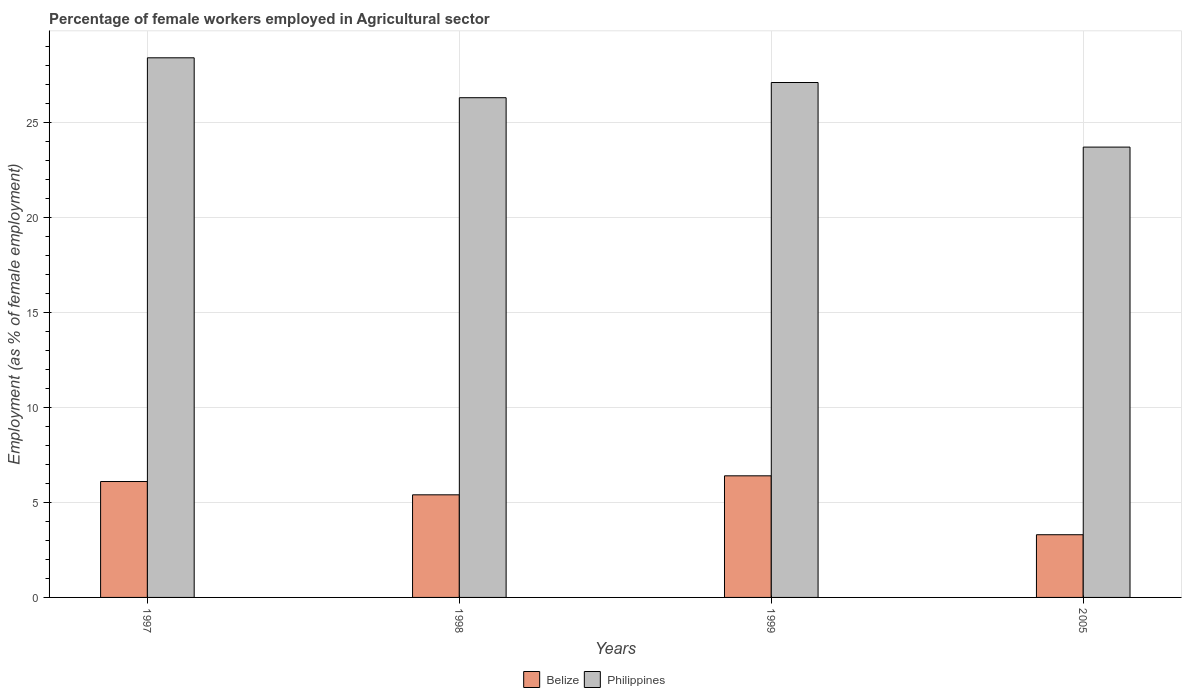How many different coloured bars are there?
Your answer should be compact. 2. Are the number of bars per tick equal to the number of legend labels?
Provide a short and direct response. Yes. How many bars are there on the 1st tick from the right?
Offer a terse response. 2. In how many cases, is the number of bars for a given year not equal to the number of legend labels?
Keep it short and to the point. 0. What is the percentage of females employed in Agricultural sector in Philippines in 1998?
Keep it short and to the point. 26.3. Across all years, what is the maximum percentage of females employed in Agricultural sector in Philippines?
Your answer should be very brief. 28.4. Across all years, what is the minimum percentage of females employed in Agricultural sector in Philippines?
Your answer should be very brief. 23.7. In which year was the percentage of females employed in Agricultural sector in Belize minimum?
Your response must be concise. 2005. What is the total percentage of females employed in Agricultural sector in Belize in the graph?
Ensure brevity in your answer.  21.2. What is the difference between the percentage of females employed in Agricultural sector in Belize in 1999 and that in 2005?
Keep it short and to the point. 3.1. What is the difference between the percentage of females employed in Agricultural sector in Philippines in 1998 and the percentage of females employed in Agricultural sector in Belize in 1997?
Offer a very short reply. 20.2. What is the average percentage of females employed in Agricultural sector in Philippines per year?
Your response must be concise. 26.37. In the year 1999, what is the difference between the percentage of females employed in Agricultural sector in Belize and percentage of females employed in Agricultural sector in Philippines?
Give a very brief answer. -20.7. In how many years, is the percentage of females employed in Agricultural sector in Philippines greater than 24 %?
Give a very brief answer. 3. What is the ratio of the percentage of females employed in Agricultural sector in Philippines in 1998 to that in 1999?
Make the answer very short. 0.97. Is the difference between the percentage of females employed in Agricultural sector in Belize in 1997 and 2005 greater than the difference between the percentage of females employed in Agricultural sector in Philippines in 1997 and 2005?
Your answer should be very brief. No. What is the difference between the highest and the second highest percentage of females employed in Agricultural sector in Belize?
Keep it short and to the point. 0.3. What is the difference between the highest and the lowest percentage of females employed in Agricultural sector in Philippines?
Provide a short and direct response. 4.7. How many bars are there?
Your answer should be very brief. 8. Are all the bars in the graph horizontal?
Offer a very short reply. No. How many years are there in the graph?
Offer a very short reply. 4. Are the values on the major ticks of Y-axis written in scientific E-notation?
Offer a terse response. No. Does the graph contain any zero values?
Give a very brief answer. No. Where does the legend appear in the graph?
Provide a short and direct response. Bottom center. What is the title of the graph?
Keep it short and to the point. Percentage of female workers employed in Agricultural sector. What is the label or title of the Y-axis?
Ensure brevity in your answer.  Employment (as % of female employment). What is the Employment (as % of female employment) of Belize in 1997?
Provide a succinct answer. 6.1. What is the Employment (as % of female employment) in Philippines in 1997?
Your response must be concise. 28.4. What is the Employment (as % of female employment) of Belize in 1998?
Your answer should be compact. 5.4. What is the Employment (as % of female employment) of Philippines in 1998?
Give a very brief answer. 26.3. What is the Employment (as % of female employment) in Belize in 1999?
Your answer should be compact. 6.4. What is the Employment (as % of female employment) in Philippines in 1999?
Provide a short and direct response. 27.1. What is the Employment (as % of female employment) of Belize in 2005?
Keep it short and to the point. 3.3. What is the Employment (as % of female employment) in Philippines in 2005?
Your answer should be very brief. 23.7. Across all years, what is the maximum Employment (as % of female employment) of Belize?
Provide a short and direct response. 6.4. Across all years, what is the maximum Employment (as % of female employment) in Philippines?
Make the answer very short. 28.4. Across all years, what is the minimum Employment (as % of female employment) of Belize?
Your answer should be compact. 3.3. Across all years, what is the minimum Employment (as % of female employment) in Philippines?
Your answer should be very brief. 23.7. What is the total Employment (as % of female employment) in Belize in the graph?
Your response must be concise. 21.2. What is the total Employment (as % of female employment) of Philippines in the graph?
Your answer should be compact. 105.5. What is the difference between the Employment (as % of female employment) of Belize in 1997 and that in 1998?
Your answer should be compact. 0.7. What is the difference between the Employment (as % of female employment) in Belize in 1997 and that in 1999?
Offer a terse response. -0.3. What is the difference between the Employment (as % of female employment) of Belize in 1997 and that in 2005?
Provide a succinct answer. 2.8. What is the difference between the Employment (as % of female employment) of Belize in 1998 and that in 1999?
Your response must be concise. -1. What is the difference between the Employment (as % of female employment) of Philippines in 1998 and that in 1999?
Offer a terse response. -0.8. What is the difference between the Employment (as % of female employment) in Belize in 1999 and that in 2005?
Ensure brevity in your answer.  3.1. What is the difference between the Employment (as % of female employment) in Philippines in 1999 and that in 2005?
Provide a short and direct response. 3.4. What is the difference between the Employment (as % of female employment) of Belize in 1997 and the Employment (as % of female employment) of Philippines in 1998?
Provide a succinct answer. -20.2. What is the difference between the Employment (as % of female employment) of Belize in 1997 and the Employment (as % of female employment) of Philippines in 1999?
Make the answer very short. -21. What is the difference between the Employment (as % of female employment) in Belize in 1997 and the Employment (as % of female employment) in Philippines in 2005?
Your response must be concise. -17.6. What is the difference between the Employment (as % of female employment) in Belize in 1998 and the Employment (as % of female employment) in Philippines in 1999?
Your answer should be compact. -21.7. What is the difference between the Employment (as % of female employment) in Belize in 1998 and the Employment (as % of female employment) in Philippines in 2005?
Provide a short and direct response. -18.3. What is the difference between the Employment (as % of female employment) of Belize in 1999 and the Employment (as % of female employment) of Philippines in 2005?
Offer a terse response. -17.3. What is the average Employment (as % of female employment) of Philippines per year?
Offer a terse response. 26.38. In the year 1997, what is the difference between the Employment (as % of female employment) of Belize and Employment (as % of female employment) of Philippines?
Provide a short and direct response. -22.3. In the year 1998, what is the difference between the Employment (as % of female employment) in Belize and Employment (as % of female employment) in Philippines?
Offer a terse response. -20.9. In the year 1999, what is the difference between the Employment (as % of female employment) of Belize and Employment (as % of female employment) of Philippines?
Give a very brief answer. -20.7. In the year 2005, what is the difference between the Employment (as % of female employment) in Belize and Employment (as % of female employment) in Philippines?
Give a very brief answer. -20.4. What is the ratio of the Employment (as % of female employment) in Belize in 1997 to that in 1998?
Ensure brevity in your answer.  1.13. What is the ratio of the Employment (as % of female employment) in Philippines in 1997 to that in 1998?
Offer a terse response. 1.08. What is the ratio of the Employment (as % of female employment) in Belize in 1997 to that in 1999?
Provide a short and direct response. 0.95. What is the ratio of the Employment (as % of female employment) in Philippines in 1997 to that in 1999?
Give a very brief answer. 1.05. What is the ratio of the Employment (as % of female employment) of Belize in 1997 to that in 2005?
Provide a succinct answer. 1.85. What is the ratio of the Employment (as % of female employment) of Philippines in 1997 to that in 2005?
Ensure brevity in your answer.  1.2. What is the ratio of the Employment (as % of female employment) in Belize in 1998 to that in 1999?
Offer a very short reply. 0.84. What is the ratio of the Employment (as % of female employment) in Philippines in 1998 to that in 1999?
Provide a short and direct response. 0.97. What is the ratio of the Employment (as % of female employment) in Belize in 1998 to that in 2005?
Make the answer very short. 1.64. What is the ratio of the Employment (as % of female employment) of Philippines in 1998 to that in 2005?
Offer a very short reply. 1.11. What is the ratio of the Employment (as % of female employment) in Belize in 1999 to that in 2005?
Provide a short and direct response. 1.94. What is the ratio of the Employment (as % of female employment) of Philippines in 1999 to that in 2005?
Offer a very short reply. 1.14. What is the difference between the highest and the second highest Employment (as % of female employment) of Philippines?
Make the answer very short. 1.3. What is the difference between the highest and the lowest Employment (as % of female employment) in Belize?
Keep it short and to the point. 3.1. 